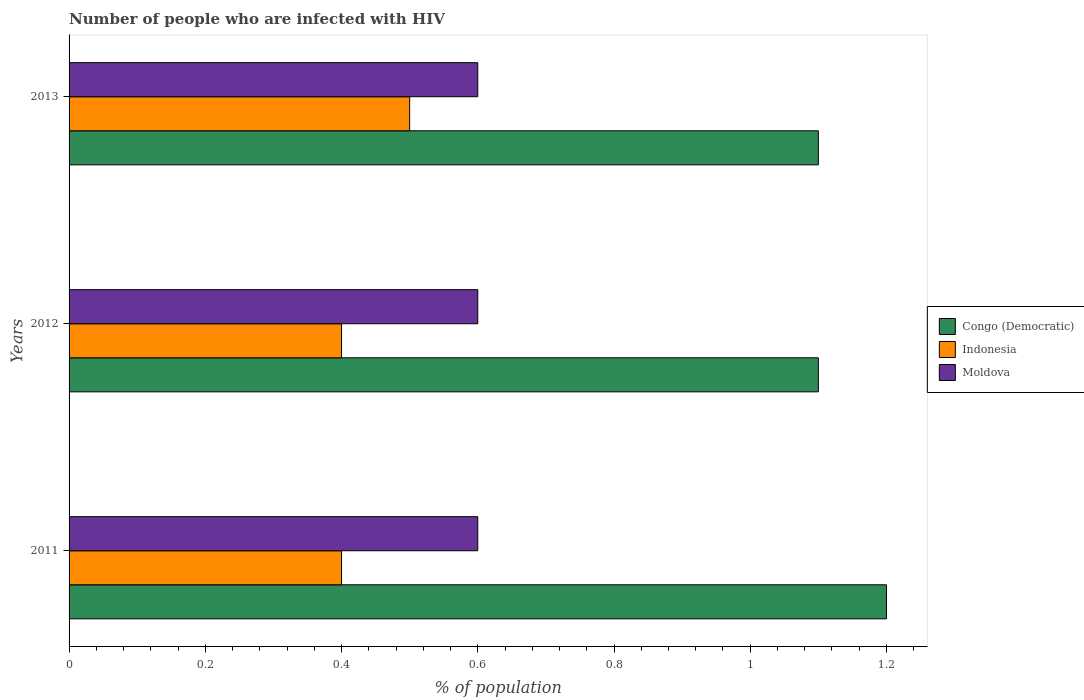How many different coloured bars are there?
Provide a succinct answer. 3. Are the number of bars on each tick of the Y-axis equal?
Make the answer very short. Yes. How many bars are there on the 2nd tick from the top?
Offer a terse response. 3. How many bars are there on the 1st tick from the bottom?
Give a very brief answer. 3. In how many cases, is the number of bars for a given year not equal to the number of legend labels?
Make the answer very short. 0. What is the percentage of HIV infected population in in Indonesia in 2011?
Give a very brief answer. 0.4. Across all years, what is the maximum percentage of HIV infected population in in Indonesia?
Your answer should be compact. 0.5. In which year was the percentage of HIV infected population in in Congo (Democratic) minimum?
Offer a very short reply. 2012. What is the difference between the percentage of HIV infected population in in Moldova in 2013 and the percentage of HIV infected population in in Indonesia in 2012?
Keep it short and to the point. 0.2. What is the average percentage of HIV infected population in in Congo (Democratic) per year?
Provide a short and direct response. 1.13. In the year 2013, what is the difference between the percentage of HIV infected population in in Congo (Democratic) and percentage of HIV infected population in in Moldova?
Your answer should be compact. 0.5. In how many years, is the percentage of HIV infected population in in Indonesia greater than 0.44 %?
Give a very brief answer. 1. What is the ratio of the percentage of HIV infected population in in Moldova in 2011 to that in 2012?
Your answer should be very brief. 1. What is the difference between the highest and the second highest percentage of HIV infected population in in Indonesia?
Ensure brevity in your answer.  0.1. What is the difference between the highest and the lowest percentage of HIV infected population in in Congo (Democratic)?
Ensure brevity in your answer.  0.1. What does the 1st bar from the top in 2013 represents?
Your response must be concise. Moldova. How many bars are there?
Keep it short and to the point. 9. Are the values on the major ticks of X-axis written in scientific E-notation?
Your response must be concise. No. Does the graph contain any zero values?
Ensure brevity in your answer.  No. Where does the legend appear in the graph?
Your response must be concise. Center right. How are the legend labels stacked?
Make the answer very short. Vertical. What is the title of the graph?
Give a very brief answer. Number of people who are infected with HIV. Does "Switzerland" appear as one of the legend labels in the graph?
Provide a succinct answer. No. What is the label or title of the X-axis?
Keep it short and to the point. % of population. What is the % of population in Congo (Democratic) in 2011?
Provide a succinct answer. 1.2. What is the % of population of Indonesia in 2012?
Offer a very short reply. 0.4. What is the % of population in Moldova in 2012?
Offer a very short reply. 0.6. What is the % of population of Congo (Democratic) in 2013?
Your response must be concise. 1.1. Across all years, what is the minimum % of population of Congo (Democratic)?
Make the answer very short. 1.1. What is the total % of population in Congo (Democratic) in the graph?
Keep it short and to the point. 3.4. What is the total % of population of Moldova in the graph?
Your answer should be compact. 1.8. What is the difference between the % of population in Congo (Democratic) in 2011 and that in 2013?
Your answer should be compact. 0.1. What is the difference between the % of population in Indonesia in 2011 and that in 2013?
Provide a succinct answer. -0.1. What is the difference between the % of population of Congo (Democratic) in 2011 and the % of population of Indonesia in 2012?
Keep it short and to the point. 0.8. What is the difference between the % of population in Congo (Democratic) in 2011 and the % of population in Moldova in 2012?
Provide a succinct answer. 0.6. What is the difference between the % of population in Congo (Democratic) in 2011 and the % of population in Indonesia in 2013?
Offer a terse response. 0.7. What is the difference between the % of population in Indonesia in 2011 and the % of population in Moldova in 2013?
Provide a succinct answer. -0.2. What is the difference between the % of population in Indonesia in 2012 and the % of population in Moldova in 2013?
Keep it short and to the point. -0.2. What is the average % of population in Congo (Democratic) per year?
Provide a short and direct response. 1.13. What is the average % of population in Indonesia per year?
Offer a very short reply. 0.43. What is the average % of population of Moldova per year?
Offer a terse response. 0.6. In the year 2011, what is the difference between the % of population of Congo (Democratic) and % of population of Indonesia?
Give a very brief answer. 0.8. In the year 2011, what is the difference between the % of population in Congo (Democratic) and % of population in Moldova?
Give a very brief answer. 0.6. In the year 2011, what is the difference between the % of population in Indonesia and % of population in Moldova?
Offer a very short reply. -0.2. In the year 2012, what is the difference between the % of population of Indonesia and % of population of Moldova?
Provide a succinct answer. -0.2. In the year 2013, what is the difference between the % of population of Congo (Democratic) and % of population of Indonesia?
Offer a terse response. 0.6. In the year 2013, what is the difference between the % of population in Congo (Democratic) and % of population in Moldova?
Give a very brief answer. 0.5. In the year 2013, what is the difference between the % of population of Indonesia and % of population of Moldova?
Keep it short and to the point. -0.1. What is the ratio of the % of population in Indonesia in 2011 to that in 2012?
Provide a succinct answer. 1. What is the ratio of the % of population in Indonesia in 2011 to that in 2013?
Make the answer very short. 0.8. What is the ratio of the % of population in Congo (Democratic) in 2012 to that in 2013?
Ensure brevity in your answer.  1. What is the ratio of the % of population in Moldova in 2012 to that in 2013?
Your answer should be compact. 1. What is the difference between the highest and the second highest % of population of Indonesia?
Give a very brief answer. 0.1. What is the difference between the highest and the second highest % of population in Moldova?
Your answer should be very brief. 0. What is the difference between the highest and the lowest % of population of Congo (Democratic)?
Offer a very short reply. 0.1. What is the difference between the highest and the lowest % of population of Indonesia?
Your response must be concise. 0.1. 